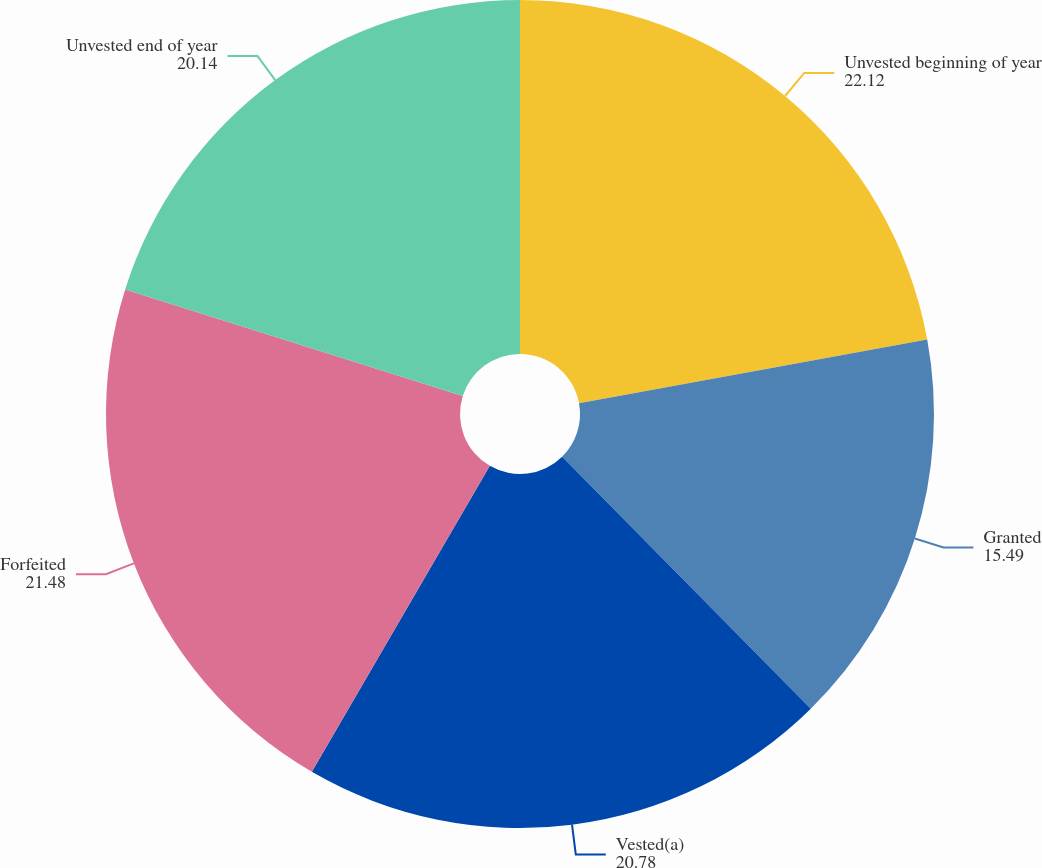<chart> <loc_0><loc_0><loc_500><loc_500><pie_chart><fcel>Unvested beginning of year<fcel>Granted<fcel>Vested(a)<fcel>Forfeited<fcel>Unvested end of year<nl><fcel>22.12%<fcel>15.49%<fcel>20.78%<fcel>21.48%<fcel>20.14%<nl></chart> 